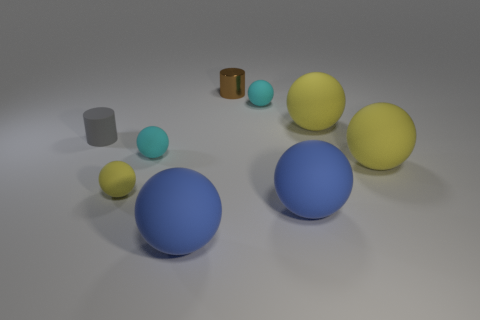Which objects in the image are closest to the camera? The two large blue spheres are the objects closest to the camera in this image. 